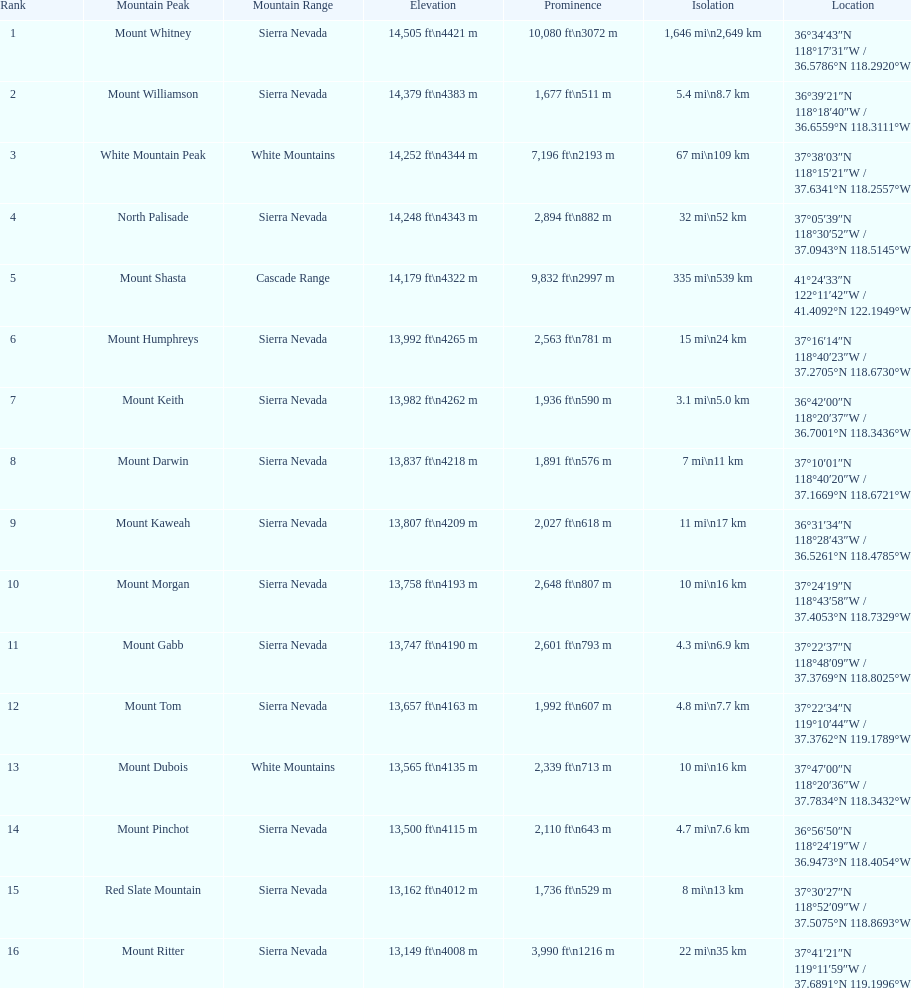What are the summit points in california? Mount Whitney, Mount Williamson, White Mountain Peak, North Palisade, Mount Shasta, Mount Humphreys, Mount Keith, Mount Darwin, Mount Kaweah, Mount Morgan, Mount Gabb, Mount Tom, Mount Dubois, Mount Pinchot, Red Slate Mountain, Mount Ritter. What are the summit points in sierra nevada, california? Mount Whitney, Mount Williamson, North Palisade, Mount Humphreys, Mount Keith, Mount Darwin, Mount Kaweah, Mount Morgan, Mount Gabb, Mount Tom, Mount Pinchot, Red Slate Mountain, Mount Ritter. What are the elevations of the peaks in sierra nevada? 14,505 ft\n4421 m, 14,379 ft\n4383 m, 14,248 ft\n4343 m, 13,992 ft\n4265 m, 13,982 ft\n4262 m, 13,837 ft\n4218 m, 13,807 ft\n4209 m, 13,758 ft\n4193 m, 13,747 ft\n4190 m, 13,657 ft\n4163 m, 13,500 ft\n4115 m, 13,162 ft\n4012 m, 13,149 ft\n4008 m. Which one has the highest altitude? Mount Whitney. 